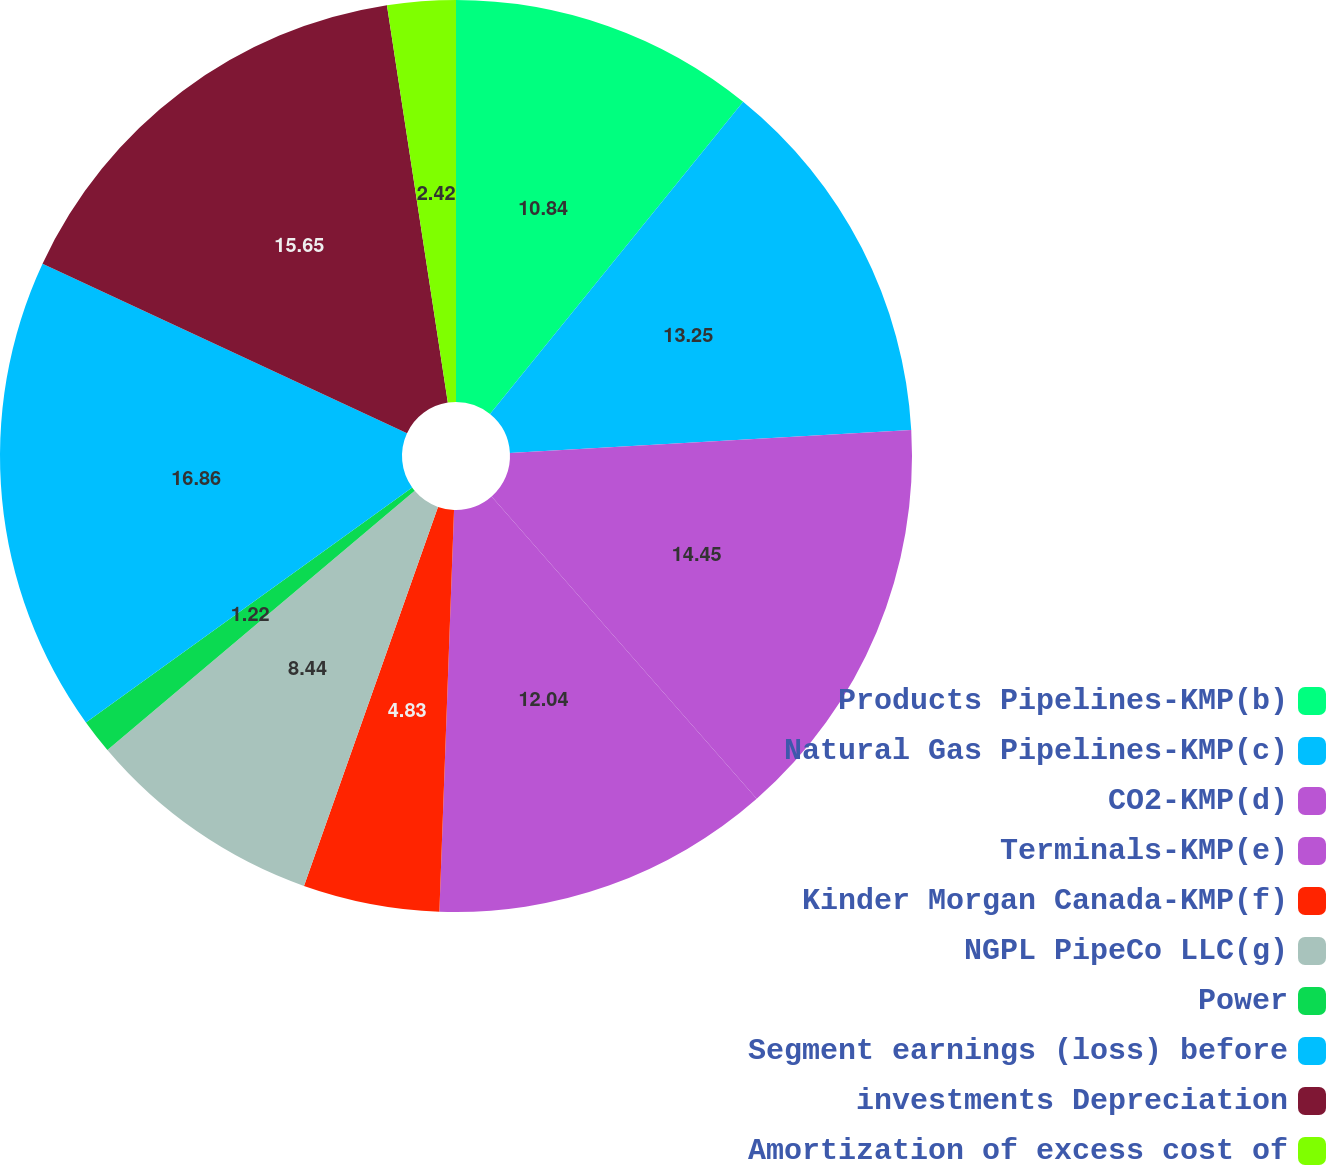Convert chart. <chart><loc_0><loc_0><loc_500><loc_500><pie_chart><fcel>Products Pipelines-KMP(b)<fcel>Natural Gas Pipelines-KMP(c)<fcel>CO2-KMP(d)<fcel>Terminals-KMP(e)<fcel>Kinder Morgan Canada-KMP(f)<fcel>NGPL PipeCo LLC(g)<fcel>Power<fcel>Segment earnings (loss) before<fcel>investments Depreciation<fcel>Amortization of excess cost of<nl><fcel>10.84%<fcel>13.25%<fcel>14.45%<fcel>12.04%<fcel>4.83%<fcel>8.44%<fcel>1.22%<fcel>16.86%<fcel>15.65%<fcel>2.42%<nl></chart> 